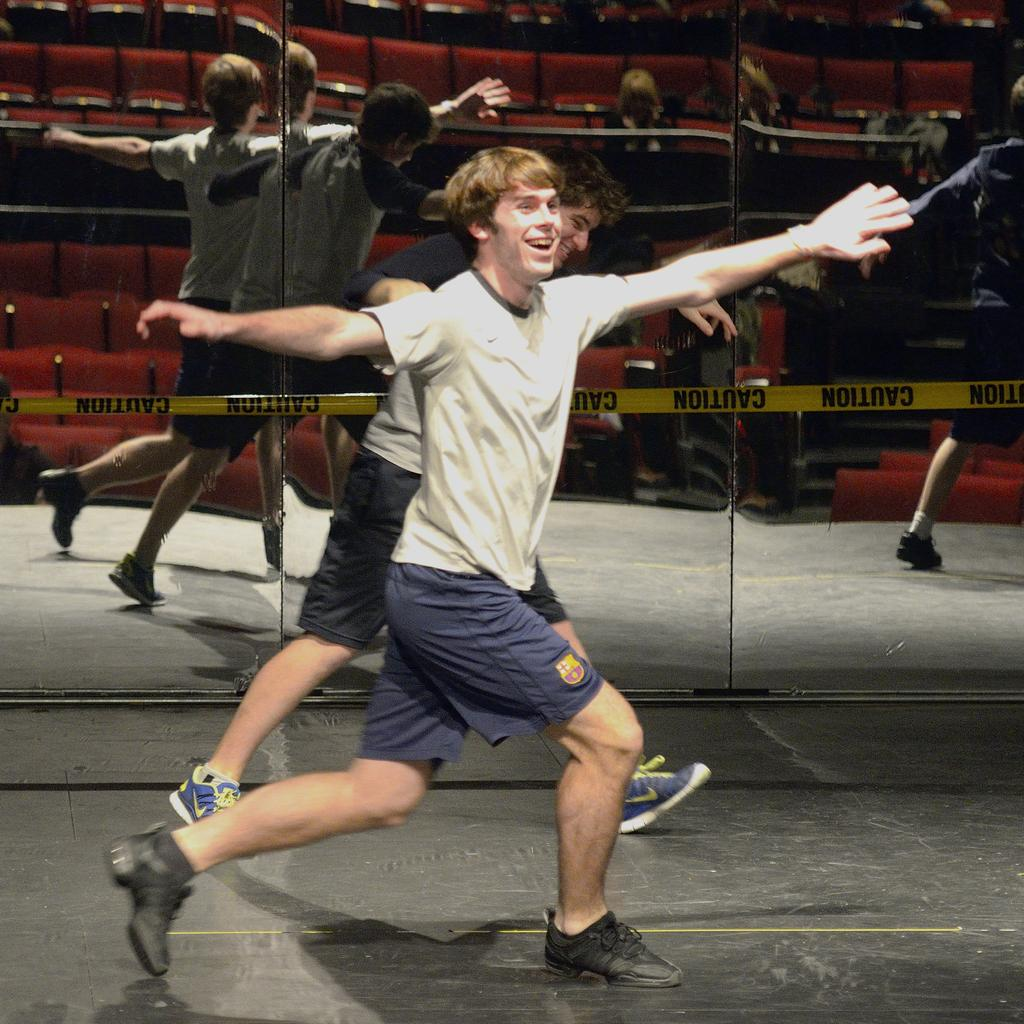What is the main subject of the image? The main subject of the image is a man. What is the man doing in the image? The man is dancing in the image. What type of clothing is the man wearing? The man is wearing a t-shirt and shorts. What color are the shoes the man is wearing? The man is wearing black color shoes. What object can be seen in the background of the image? There is a glass mirror in the image. What type of weather can be seen in the image? The image does not depict any weather conditions; it is an indoor scene with a man dancing. What type of brain activity can be observed in the image? The image does not show any brain activity; it is a photograph of a man dancing. 